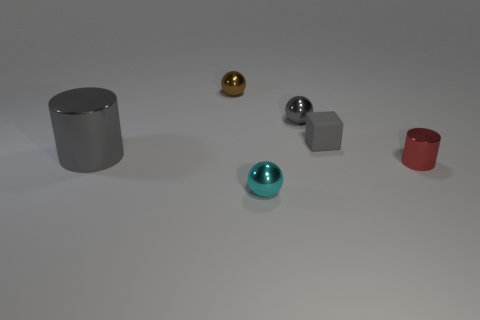Add 2 big yellow blocks. How many objects exist? 8 Subtract all cubes. How many objects are left? 5 Add 3 green shiny blocks. How many green shiny blocks exist? 3 Subtract 0 green spheres. How many objects are left? 6 Subtract all small matte objects. Subtract all shiny cylinders. How many objects are left? 3 Add 3 tiny cyan things. How many tiny cyan things are left? 4 